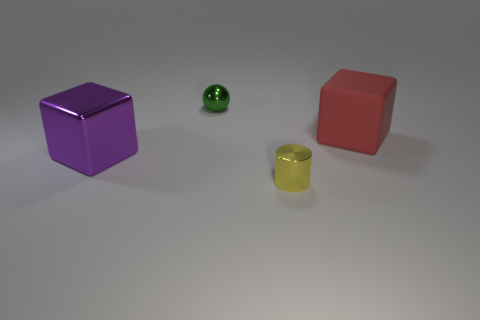Is there any other thing that is the same material as the big red thing?
Provide a succinct answer. No. How many things are either large metallic cubes in front of the red cube or big blocks on the left side of the large red block?
Offer a terse response. 1. What number of other objects are the same color as the big metal object?
Offer a terse response. 0. What is the yellow thing made of?
Give a very brief answer. Metal. Does the metal cylinder that is in front of the red matte thing have the same size as the tiny metallic sphere?
Your response must be concise. Yes. What size is the shiny thing that is the same shape as the large matte object?
Provide a short and direct response. Large. Are there an equal number of large purple objects that are in front of the large purple object and tiny objects that are in front of the tiny green metallic thing?
Provide a short and direct response. No. How big is the thing behind the large red cube?
Give a very brief answer. Small. Is there any other thing that is the same shape as the small green metal object?
Your answer should be compact. No. Is the number of tiny yellow metal cylinders that are left of the yellow metal object the same as the number of spheres?
Give a very brief answer. No. 